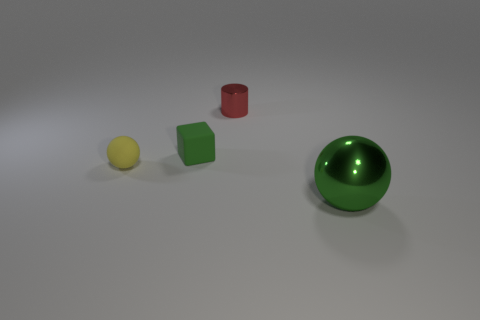Do the small thing that is on the right side of the tiny green matte cube and the green thing to the right of the tiny green object have the same material?
Provide a succinct answer. Yes. There is a tiny rubber thing that is left of the tiny green rubber object; are there any large green metal things to the left of it?
Give a very brief answer. No. There is a object that is made of the same material as the tiny yellow ball; what color is it?
Offer a very short reply. Green. Are there more large objects than cyan metal spheres?
Keep it short and to the point. Yes. How many things are either metal objects to the left of the large green thing or green objects?
Your answer should be compact. 3. Is there a red thing of the same size as the yellow sphere?
Your answer should be very brief. Yes. Is the number of tiny yellow things less than the number of big gray objects?
Your answer should be compact. No. What number of blocks are large things or tiny gray matte objects?
Keep it short and to the point. 0. What number of matte objects have the same color as the tiny metal object?
Ensure brevity in your answer.  0. There is a thing that is behind the yellow thing and in front of the small red metallic thing; what size is it?
Give a very brief answer. Small. 